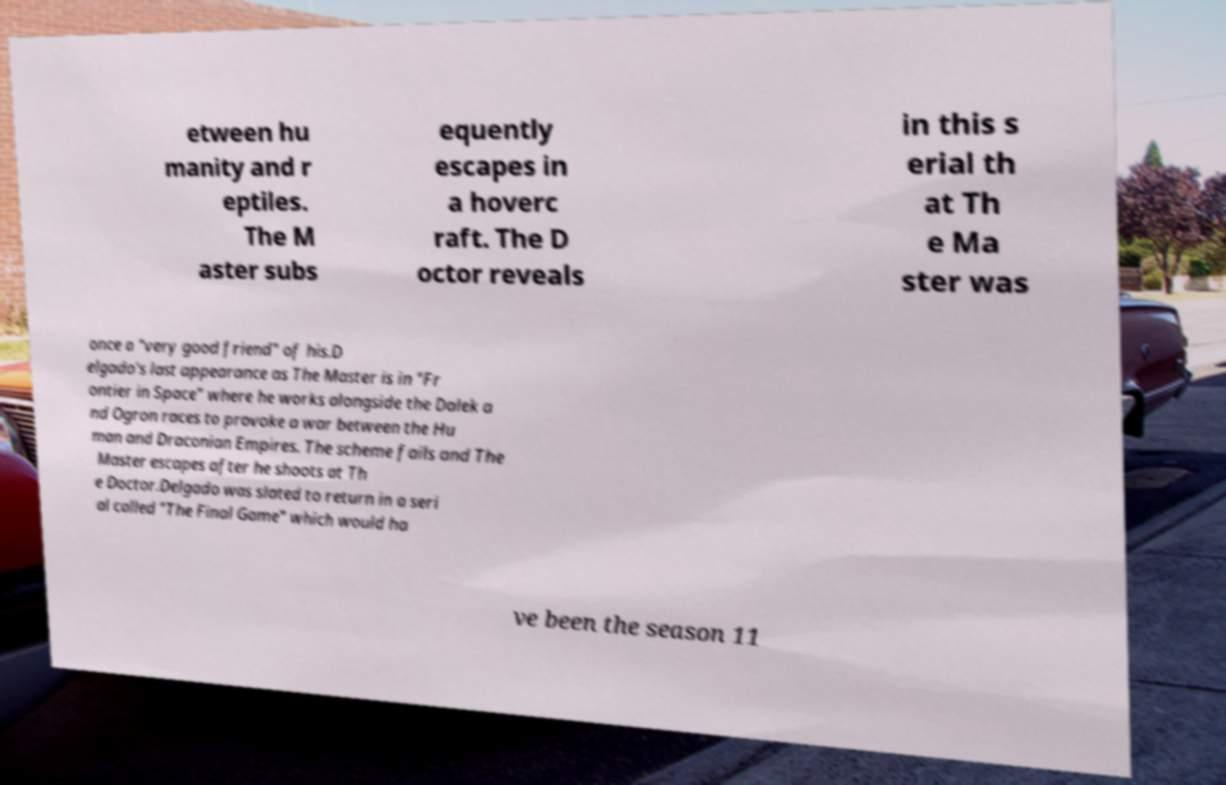For documentation purposes, I need the text within this image transcribed. Could you provide that? etween hu manity and r eptiles. The M aster subs equently escapes in a hoverc raft. The D octor reveals in this s erial th at Th e Ma ster was once a "very good friend" of his.D elgado's last appearance as The Master is in "Fr ontier in Space" where he works alongside the Dalek a nd Ogron races to provoke a war between the Hu man and Draconian Empires. The scheme fails and The Master escapes after he shoots at Th e Doctor.Delgado was slated to return in a seri al called "The Final Game" which would ha ve been the season 11 